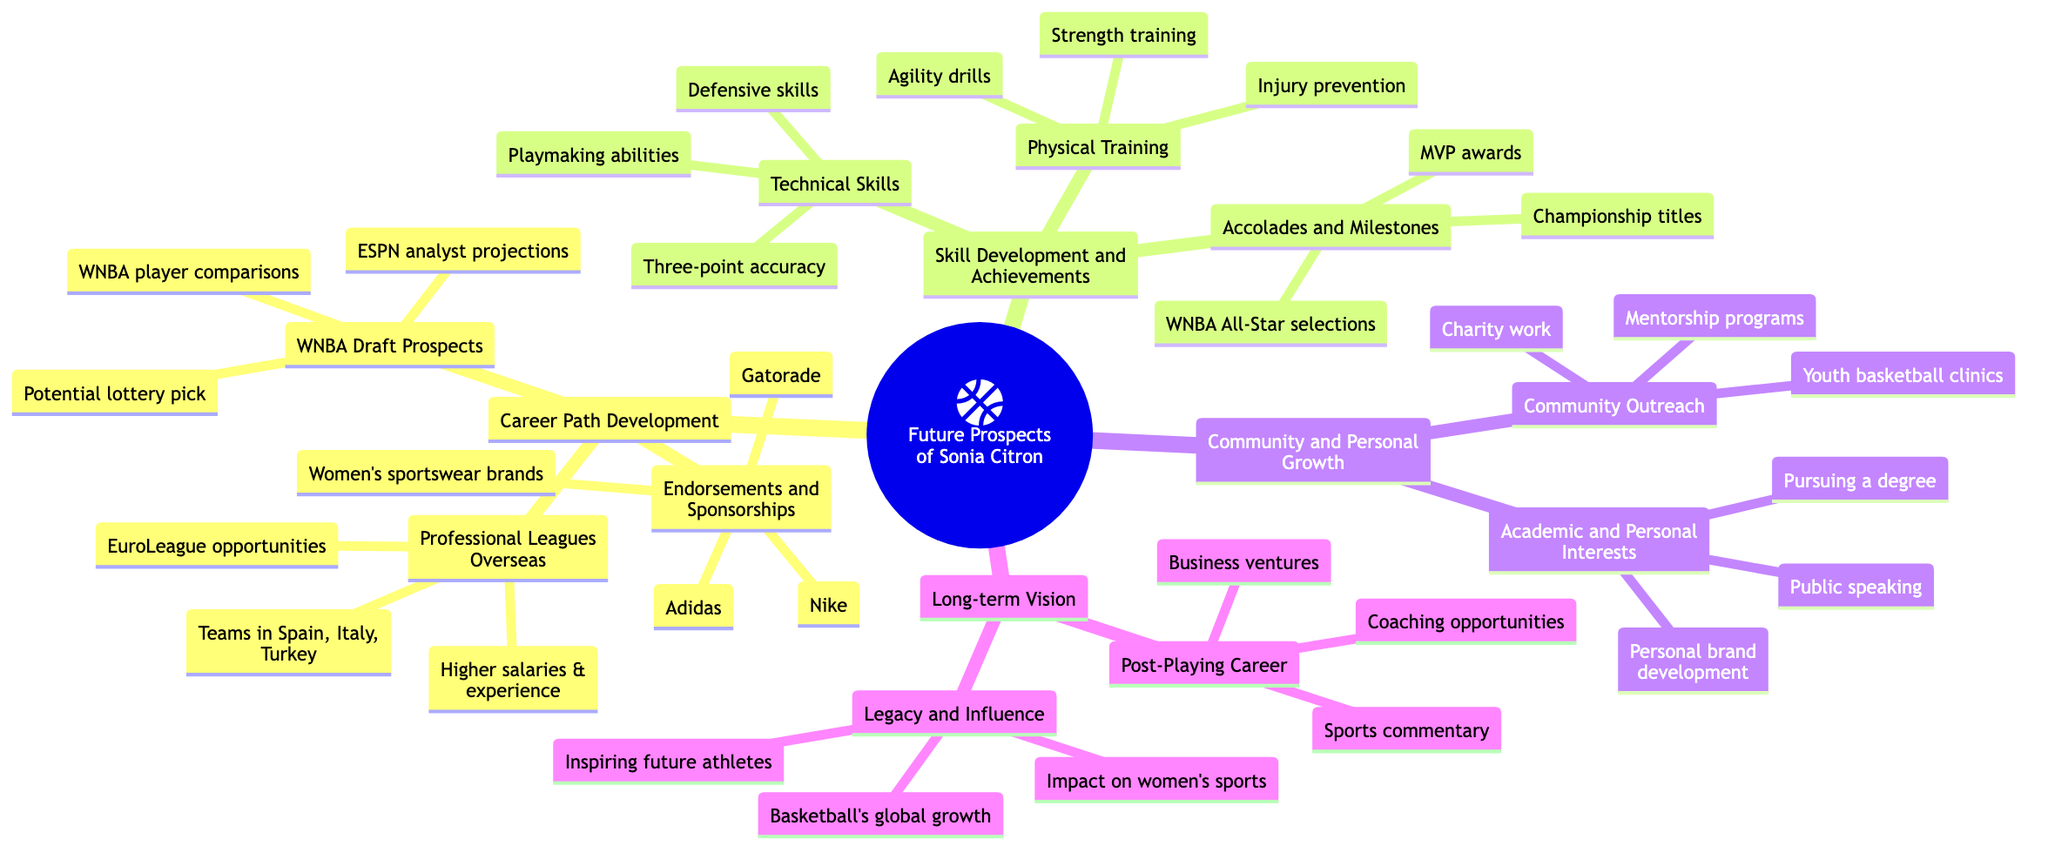What is the central topic of the mind map? The central topic displayed at the root of the mind map is "Future Prospects of Sonia Citron." This can be identified as it forms the main focus from which other subtopics branch out.
Answer: Future Prospects of Sonia Citron How many main subtopics are there? By counting the number of primary categories branching directly from the central topic, we find there are four main subtopics: Career Path Development, Skill Development and Achievements, Community and Personal Growth, and Long-term Vision.
Answer: 4 What potential endorsement brands are mentioned? The diagram lists several brands under endorsements and sponsorships, specifically Nike, Adidas, and Gatorade, along with a potential for partnerships with women's sportswear brands.
Answer: Nike, Adidas, Gatorade Which area includes physical training? The subtopic "Physical Training" appears under the main category "Skill Development and Achievements," indicating it focuses on the enhancement of Sonia Citron's physical aspects of her game.
Answer: Skill Development and Achievements What opportunities are mentioned in "Professional Leagues Overseas"? The subtopic encompasses various opportunities such as EuroLeague, teams located in Spain, Italy, and Turkey, and the possibility for higher salaries and experience. These details illustrate her options if she chooses to play abroad.
Answer: EuroLeague opportunities, Teams in Spain, Italy, Turkey, Higher salaries & experience What is included in "Post-Playing Career"? The "Post-Playing Career" section outlines potential future endeavors after her playing days, specifying coaching opportunities, sports commentary, and business ventures, showing a broad perspective on her career after basketball.
Answer: Coaching opportunities, Sports commentary, Business ventures How are her achievements categorized? Achievements are classified under the "Accolades and Milestones" section, featuring notable accomplishments such as WNBA All-Star selections, Championship titles, and MVP awards, which highlight her success in basketball.
Answer: WNBA All-Star selections, Championship titles, MVP awards What type of community outreach does Sonia Citron engage in? The mind map lists multiple community engagement activities including basketball clinics for the youth, charity work, and mentorship programs, emphasizing her involvement and impact off the court.
Answer: Youth basketball clinics, Charity work, Mentorship programs Which skills are highlighted under technical skills? The technical skills mentioned encompass three-point shooting accuracy, defensive skills, and playmaking abilities, showcasing her areas of proficiency necessary for success in basketball.
Answer: Three-point shooting accuracy, Defensive skills, Playmaking abilities 